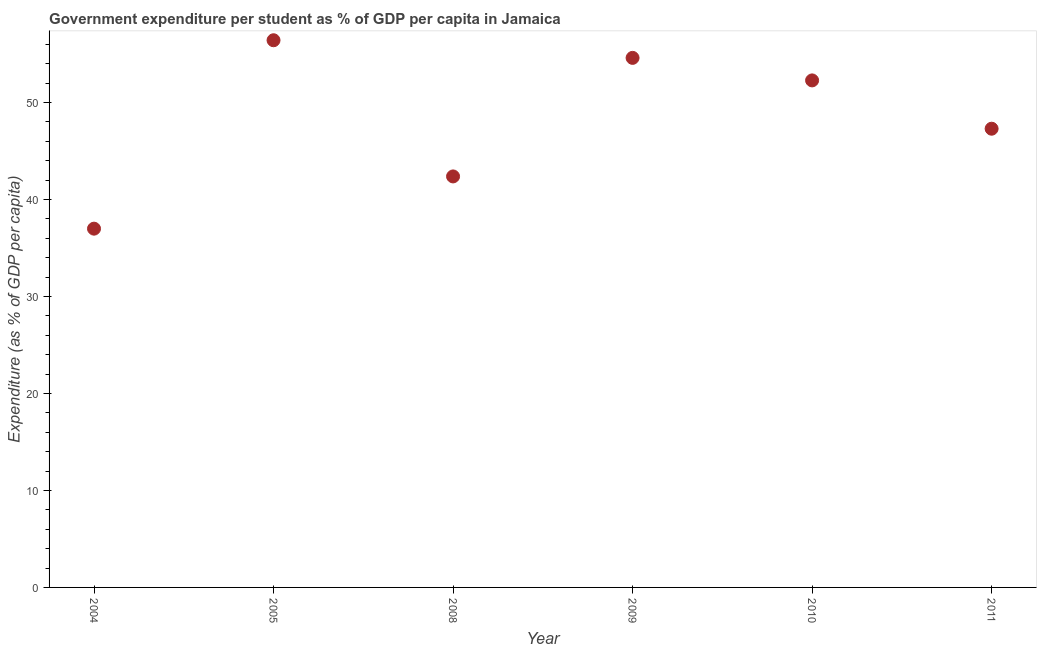What is the government expenditure per student in 2009?
Provide a succinct answer. 54.6. Across all years, what is the maximum government expenditure per student?
Provide a succinct answer. 56.42. Across all years, what is the minimum government expenditure per student?
Provide a succinct answer. 36.99. In which year was the government expenditure per student maximum?
Your answer should be compact. 2005. What is the sum of the government expenditure per student?
Offer a very short reply. 289.95. What is the difference between the government expenditure per student in 2008 and 2009?
Your answer should be compact. -12.22. What is the average government expenditure per student per year?
Ensure brevity in your answer.  48.33. What is the median government expenditure per student?
Offer a very short reply. 49.79. What is the ratio of the government expenditure per student in 2008 to that in 2010?
Your response must be concise. 0.81. Is the government expenditure per student in 2008 less than that in 2009?
Provide a short and direct response. Yes. What is the difference between the highest and the second highest government expenditure per student?
Give a very brief answer. 1.82. What is the difference between the highest and the lowest government expenditure per student?
Your answer should be very brief. 19.43. How many years are there in the graph?
Ensure brevity in your answer.  6. Are the values on the major ticks of Y-axis written in scientific E-notation?
Your answer should be very brief. No. What is the title of the graph?
Your answer should be very brief. Government expenditure per student as % of GDP per capita in Jamaica. What is the label or title of the Y-axis?
Offer a terse response. Expenditure (as % of GDP per capita). What is the Expenditure (as % of GDP per capita) in 2004?
Offer a terse response. 36.99. What is the Expenditure (as % of GDP per capita) in 2005?
Provide a short and direct response. 56.42. What is the Expenditure (as % of GDP per capita) in 2008?
Ensure brevity in your answer.  42.38. What is the Expenditure (as % of GDP per capita) in 2009?
Make the answer very short. 54.6. What is the Expenditure (as % of GDP per capita) in 2010?
Your answer should be very brief. 52.28. What is the Expenditure (as % of GDP per capita) in 2011?
Offer a terse response. 47.3. What is the difference between the Expenditure (as % of GDP per capita) in 2004 and 2005?
Your answer should be very brief. -19.43. What is the difference between the Expenditure (as % of GDP per capita) in 2004 and 2008?
Ensure brevity in your answer.  -5.39. What is the difference between the Expenditure (as % of GDP per capita) in 2004 and 2009?
Your answer should be compact. -17.61. What is the difference between the Expenditure (as % of GDP per capita) in 2004 and 2010?
Provide a short and direct response. -15.29. What is the difference between the Expenditure (as % of GDP per capita) in 2004 and 2011?
Your response must be concise. -10.31. What is the difference between the Expenditure (as % of GDP per capita) in 2005 and 2008?
Offer a very short reply. 14.04. What is the difference between the Expenditure (as % of GDP per capita) in 2005 and 2009?
Ensure brevity in your answer.  1.82. What is the difference between the Expenditure (as % of GDP per capita) in 2005 and 2010?
Offer a terse response. 4.14. What is the difference between the Expenditure (as % of GDP per capita) in 2005 and 2011?
Your answer should be compact. 9.12. What is the difference between the Expenditure (as % of GDP per capita) in 2008 and 2009?
Provide a short and direct response. -12.22. What is the difference between the Expenditure (as % of GDP per capita) in 2008 and 2010?
Ensure brevity in your answer.  -9.9. What is the difference between the Expenditure (as % of GDP per capita) in 2008 and 2011?
Your answer should be very brief. -4.92. What is the difference between the Expenditure (as % of GDP per capita) in 2009 and 2010?
Keep it short and to the point. 2.32. What is the difference between the Expenditure (as % of GDP per capita) in 2009 and 2011?
Your answer should be very brief. 7.3. What is the difference between the Expenditure (as % of GDP per capita) in 2010 and 2011?
Keep it short and to the point. 4.98. What is the ratio of the Expenditure (as % of GDP per capita) in 2004 to that in 2005?
Ensure brevity in your answer.  0.66. What is the ratio of the Expenditure (as % of GDP per capita) in 2004 to that in 2008?
Your answer should be compact. 0.87. What is the ratio of the Expenditure (as % of GDP per capita) in 2004 to that in 2009?
Your answer should be compact. 0.68. What is the ratio of the Expenditure (as % of GDP per capita) in 2004 to that in 2010?
Keep it short and to the point. 0.71. What is the ratio of the Expenditure (as % of GDP per capita) in 2004 to that in 2011?
Offer a very short reply. 0.78. What is the ratio of the Expenditure (as % of GDP per capita) in 2005 to that in 2008?
Provide a short and direct response. 1.33. What is the ratio of the Expenditure (as % of GDP per capita) in 2005 to that in 2009?
Ensure brevity in your answer.  1.03. What is the ratio of the Expenditure (as % of GDP per capita) in 2005 to that in 2010?
Offer a very short reply. 1.08. What is the ratio of the Expenditure (as % of GDP per capita) in 2005 to that in 2011?
Offer a very short reply. 1.19. What is the ratio of the Expenditure (as % of GDP per capita) in 2008 to that in 2009?
Provide a succinct answer. 0.78. What is the ratio of the Expenditure (as % of GDP per capita) in 2008 to that in 2010?
Give a very brief answer. 0.81. What is the ratio of the Expenditure (as % of GDP per capita) in 2008 to that in 2011?
Your answer should be very brief. 0.9. What is the ratio of the Expenditure (as % of GDP per capita) in 2009 to that in 2010?
Provide a short and direct response. 1.04. What is the ratio of the Expenditure (as % of GDP per capita) in 2009 to that in 2011?
Keep it short and to the point. 1.15. What is the ratio of the Expenditure (as % of GDP per capita) in 2010 to that in 2011?
Provide a succinct answer. 1.1. 